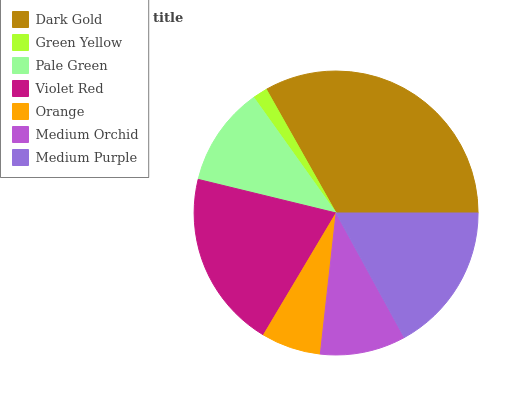Is Green Yellow the minimum?
Answer yes or no. Yes. Is Dark Gold the maximum?
Answer yes or no. Yes. Is Pale Green the minimum?
Answer yes or no. No. Is Pale Green the maximum?
Answer yes or no. No. Is Pale Green greater than Green Yellow?
Answer yes or no. Yes. Is Green Yellow less than Pale Green?
Answer yes or no. Yes. Is Green Yellow greater than Pale Green?
Answer yes or no. No. Is Pale Green less than Green Yellow?
Answer yes or no. No. Is Pale Green the high median?
Answer yes or no. Yes. Is Pale Green the low median?
Answer yes or no. Yes. Is Orange the high median?
Answer yes or no. No. Is Medium Orchid the low median?
Answer yes or no. No. 